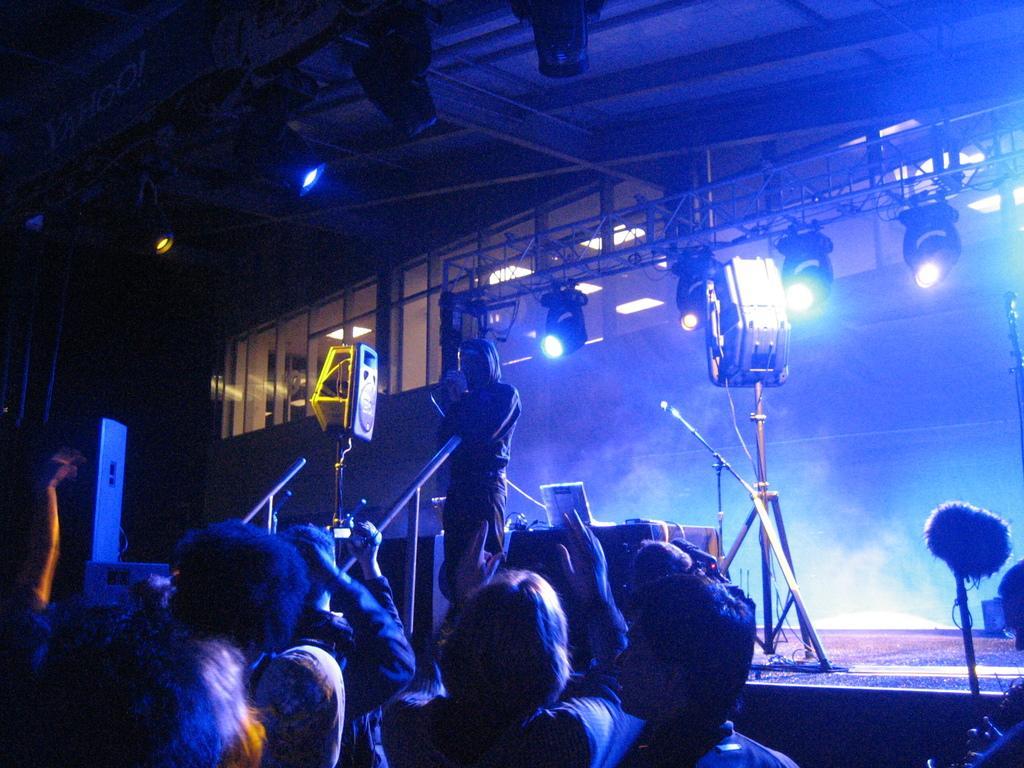In one or two sentences, can you explain what this image depicts? In this image, there are a few people. Among them, we can see a person on the stage. We can see some poles and microphones. We can also see some lights on the roof and on a metal pole. We can see some windows and the roof. We can also see a table covered with a cloth with some objects on it. 